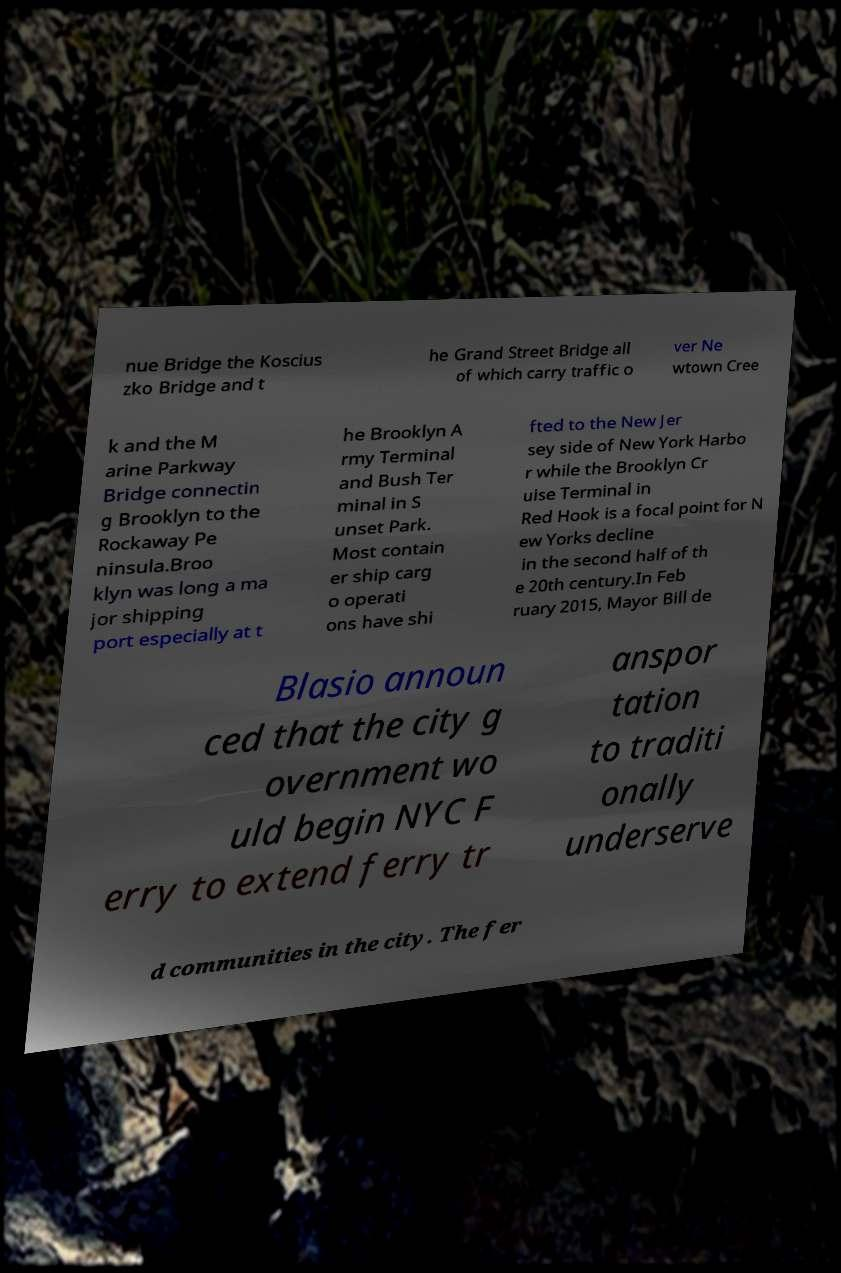I need the written content from this picture converted into text. Can you do that? nue Bridge the Koscius zko Bridge and t he Grand Street Bridge all of which carry traffic o ver Ne wtown Cree k and the M arine Parkway Bridge connectin g Brooklyn to the Rockaway Pe ninsula.Broo klyn was long a ma jor shipping port especially at t he Brooklyn A rmy Terminal and Bush Ter minal in S unset Park. Most contain er ship carg o operati ons have shi fted to the New Jer sey side of New York Harbo r while the Brooklyn Cr uise Terminal in Red Hook is a focal point for N ew Yorks decline in the second half of th e 20th century.In Feb ruary 2015, Mayor Bill de Blasio announ ced that the city g overnment wo uld begin NYC F erry to extend ferry tr anspor tation to traditi onally underserve d communities in the city. The fer 